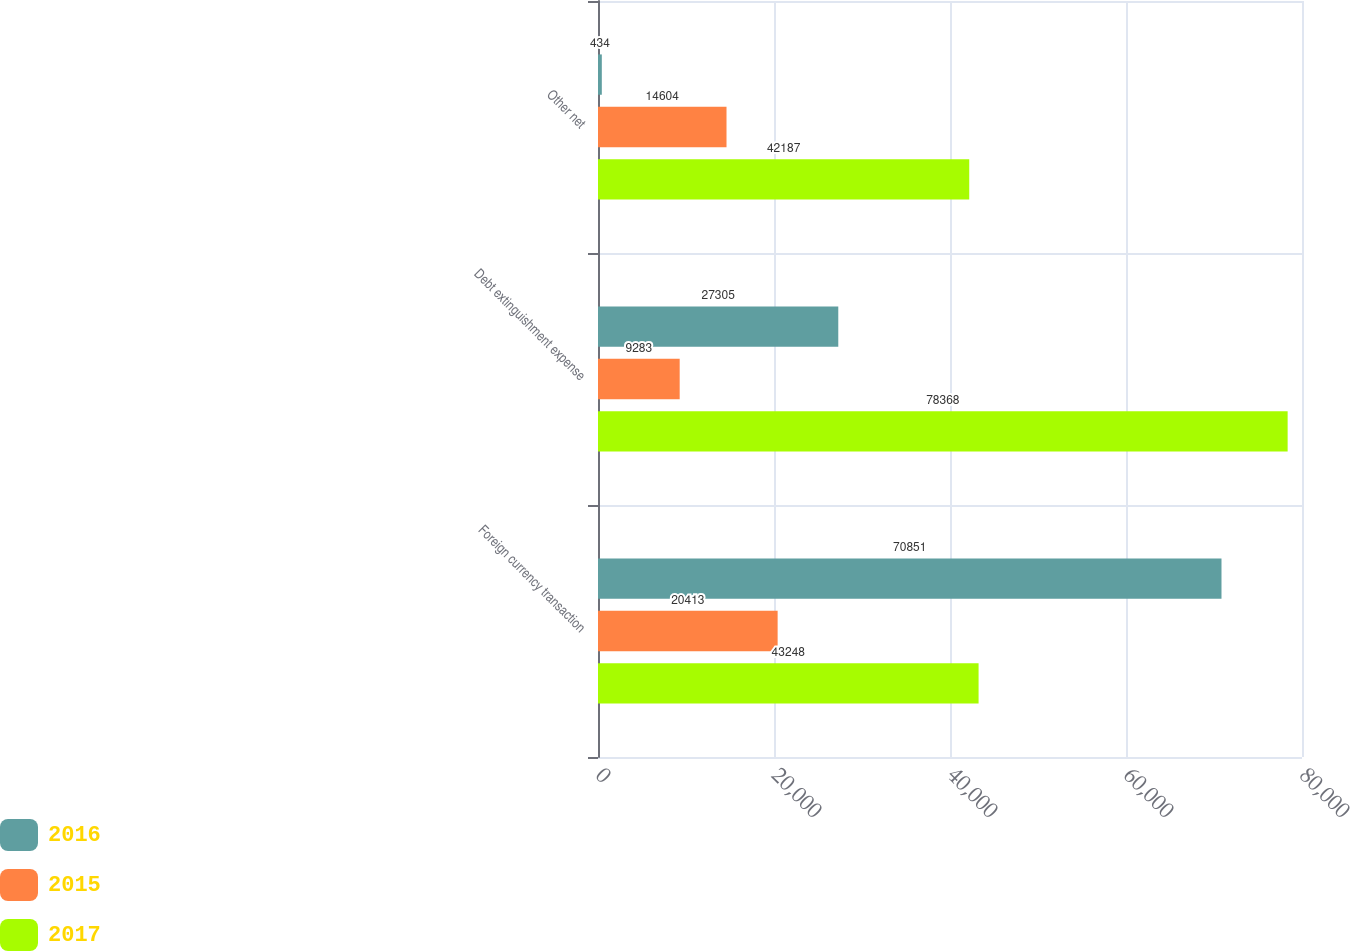Convert chart to OTSL. <chart><loc_0><loc_0><loc_500><loc_500><stacked_bar_chart><ecel><fcel>Foreign currency transaction<fcel>Debt extinguishment expense<fcel>Other net<nl><fcel>2016<fcel>70851<fcel>27305<fcel>434<nl><fcel>2015<fcel>20413<fcel>9283<fcel>14604<nl><fcel>2017<fcel>43248<fcel>78368<fcel>42187<nl></chart> 